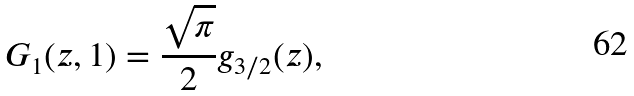<formula> <loc_0><loc_0><loc_500><loc_500>G _ { 1 } ( z , 1 ) = \frac { \sqrt { \pi } } { 2 } g _ { 3 / 2 } ( z ) ,</formula> 